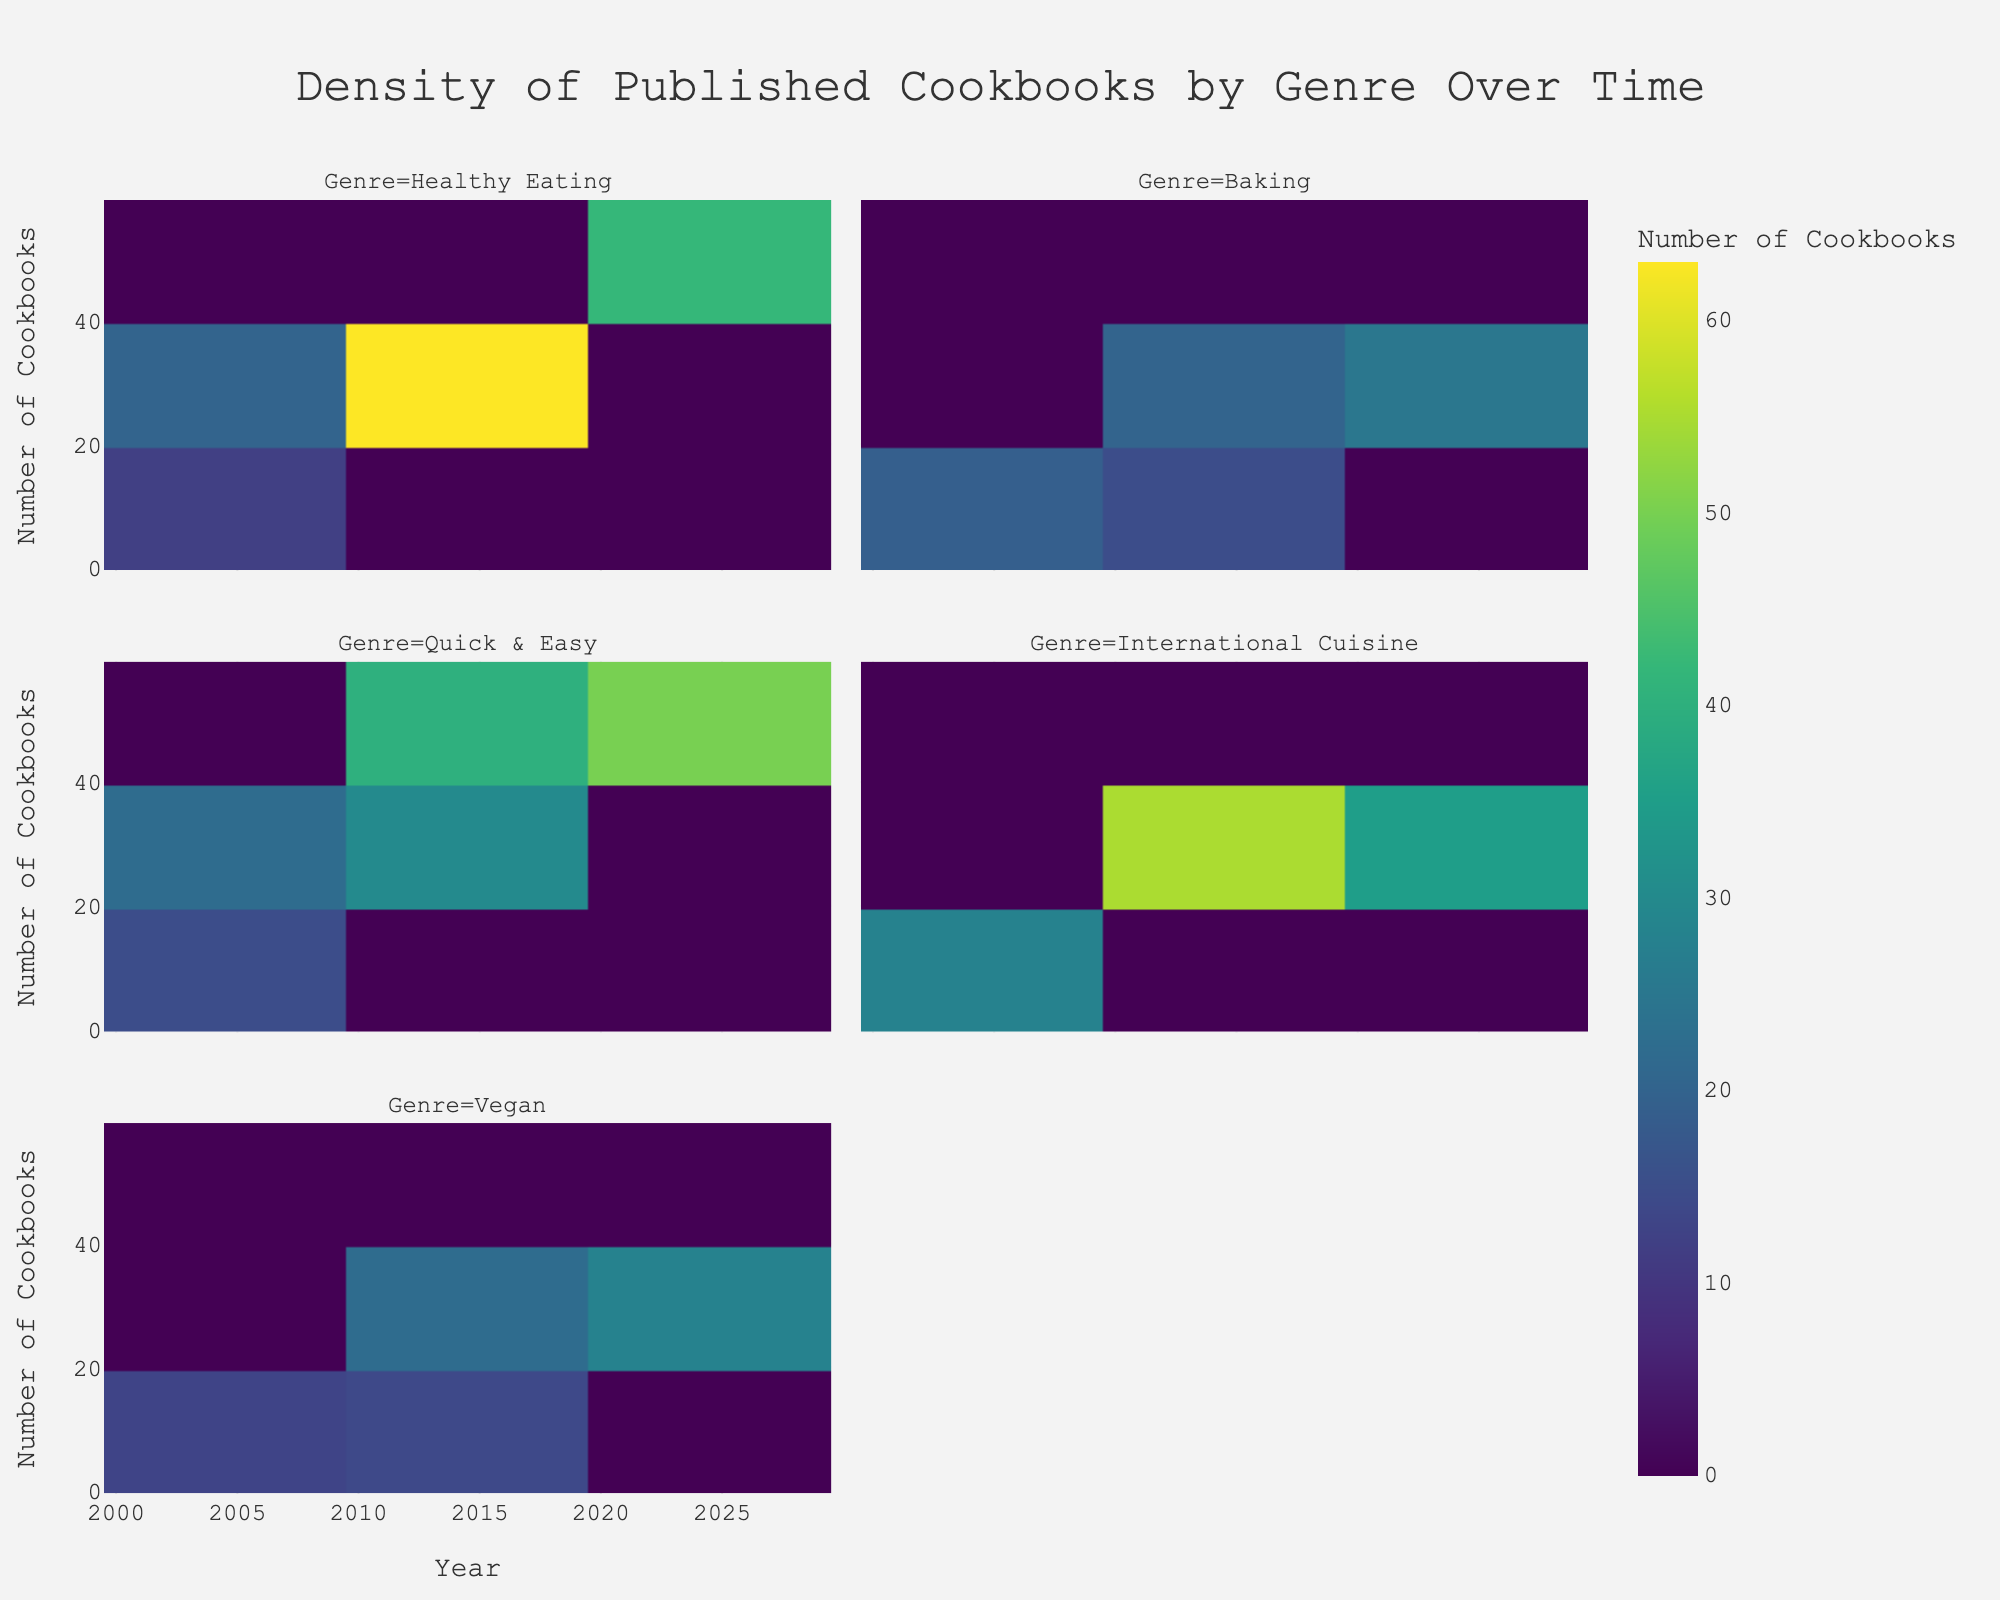What is the title of the figure? The title is typically placed at the top of the figure and is clearly readable. It summarizes what the figure represents.
Answer: Density of Published Cookbooks by Genre Over Time Which genre had the highest number of cookbooks published in 2020? Look at the columns labeled by Genre and the density values for the year 2020 to determine which one has the highest count.
Answer: Quick & Easy How does the number of published cookbooks in the "Baking" genre change over time? Observe the density values within the "Baking" genre across all represented years and note if the count increases, decreases, or remains the same.
Answer: It increases steadily Which two genres had an equal number of cookbooks published in 2000? Compare the values for each genre in the year 2000 and identify any with equal counts.
Answer: International Cuisine and Baking What is the difference in the number of "Vegan" cookbooks published between 2010 and 2020? Find and subtract the value for "Vegan" cookbooks in 2010 from the value in 2020.
Answer: 14 How many genres had a count above 20 cookbooks in 2015? Identify the genres with a count greater than 20 in 2015 by reviewing each facet for the respective year.
Answer: Four Compare the popularity trends of "Healthy Eating" and "Quick & Easy" from 2000 to 2020. Look at how the counts of cookbooks in these genres change over the years and identify whether each increases, decreases, or remains constant.
Answer: Both increase, with "Quick & Easy" increasing more rapidly What is the average number of cookbooks published per genre in 2015? Sum the counts for all genres in 2015 and divide by the number of genres. (35 + 20 + 40 + 30 + 22) / 5 = 29.4
Answer: 29.4 Which genre shows the least variability in the number of cookbooks published over time? Compare the spread of the densities in each genre's facet to see which remains most constant.
Answer: Baking How does the increase in number of "International Cuisine" cookbooks compare to "Vegan" cookbooks from 2005 to 2015? Calculate the change in counts for both genres from 2005 to 2015 and compare them. International Cuisine: 30 - 18 = 12, Vegan: 22 - 8 = 14.
Answer: Vegan increased more 